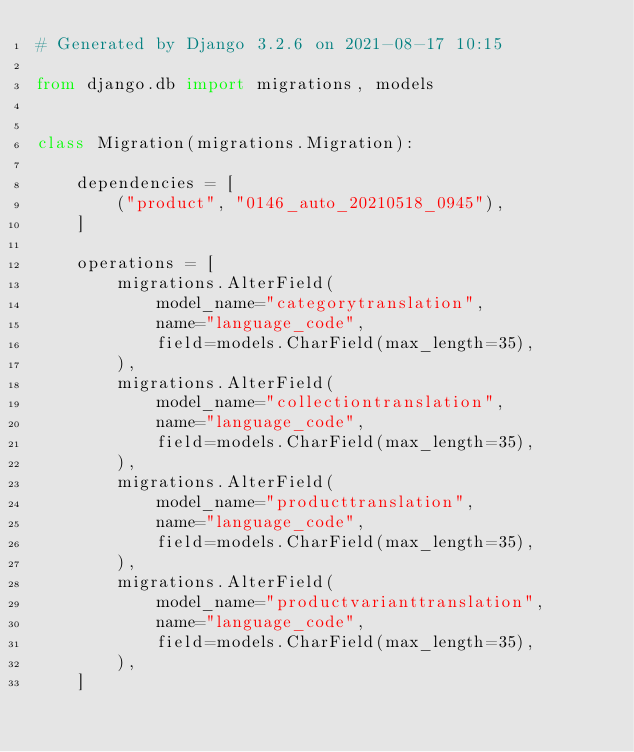<code> <loc_0><loc_0><loc_500><loc_500><_Python_># Generated by Django 3.2.6 on 2021-08-17 10:15

from django.db import migrations, models


class Migration(migrations.Migration):

    dependencies = [
        ("product", "0146_auto_20210518_0945"),
    ]

    operations = [
        migrations.AlterField(
            model_name="categorytranslation",
            name="language_code",
            field=models.CharField(max_length=35),
        ),
        migrations.AlterField(
            model_name="collectiontranslation",
            name="language_code",
            field=models.CharField(max_length=35),
        ),
        migrations.AlterField(
            model_name="producttranslation",
            name="language_code",
            field=models.CharField(max_length=35),
        ),
        migrations.AlterField(
            model_name="productvarianttranslation",
            name="language_code",
            field=models.CharField(max_length=35),
        ),
    ]
</code> 